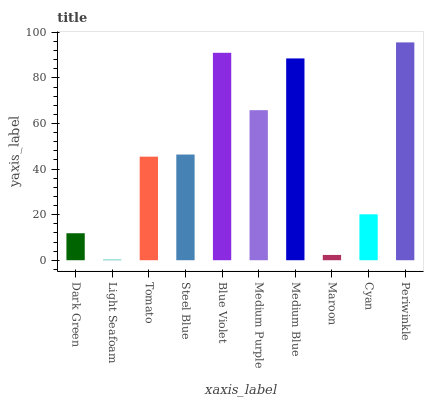Is Light Seafoam the minimum?
Answer yes or no. Yes. Is Periwinkle the maximum?
Answer yes or no. Yes. Is Tomato the minimum?
Answer yes or no. No. Is Tomato the maximum?
Answer yes or no. No. Is Tomato greater than Light Seafoam?
Answer yes or no. Yes. Is Light Seafoam less than Tomato?
Answer yes or no. Yes. Is Light Seafoam greater than Tomato?
Answer yes or no. No. Is Tomato less than Light Seafoam?
Answer yes or no. No. Is Steel Blue the high median?
Answer yes or no. Yes. Is Tomato the low median?
Answer yes or no. Yes. Is Blue Violet the high median?
Answer yes or no. No. Is Medium Purple the low median?
Answer yes or no. No. 